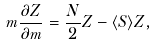Convert formula to latex. <formula><loc_0><loc_0><loc_500><loc_500>m \frac { \partial Z } { \partial m } = \frac { N } { 2 } Z - \langle S \rangle Z ,</formula> 